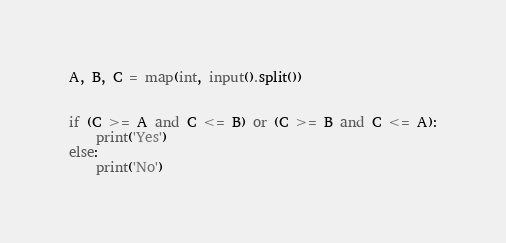Convert code to text. <code><loc_0><loc_0><loc_500><loc_500><_Python_>A, B, C = map(int, input().split())


if (C >= A and C <= B) or (C >= B and C <= A):
    print('Yes')
else:
    print('No')</code> 